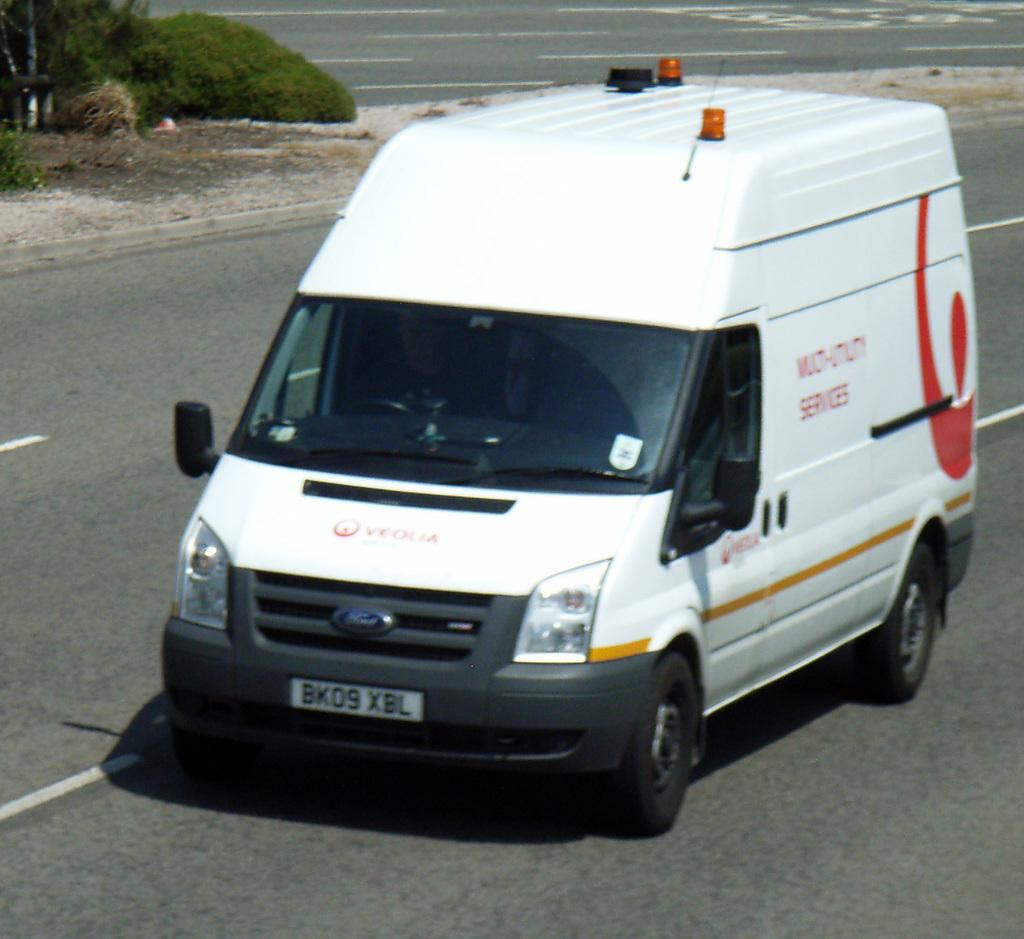Provide a one-sentence caption for the provided image. a white Ford van has a plate BK09 XBL. 